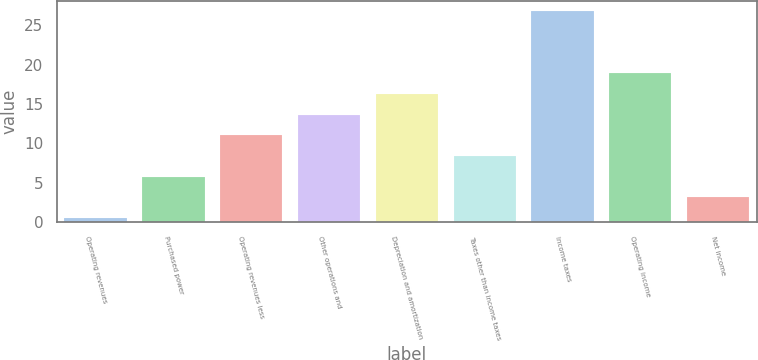Convert chart to OTSL. <chart><loc_0><loc_0><loc_500><loc_500><bar_chart><fcel>Operating revenues<fcel>Purchased power<fcel>Operating revenues less<fcel>Other operations and<fcel>Depreciation and amortization<fcel>Taxes other than income taxes<fcel>Income taxes<fcel>Operating income<fcel>Net income<nl><fcel>0.5<fcel>5.76<fcel>11.02<fcel>13.65<fcel>16.28<fcel>8.39<fcel>26.8<fcel>18.91<fcel>3.13<nl></chart> 